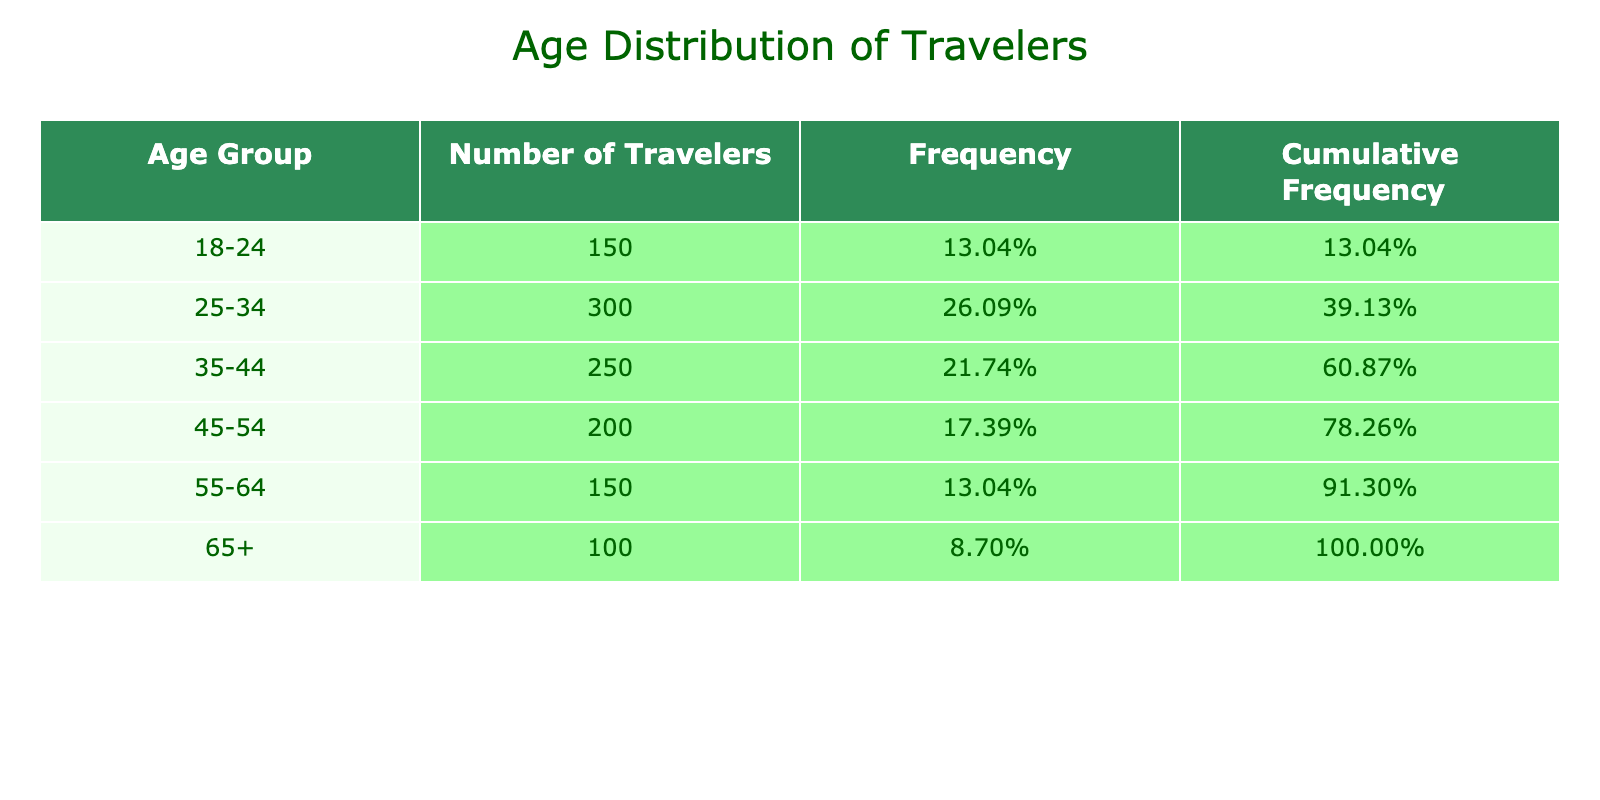What is the number of travelers in the age group 25-34? The table lists the number of travelers in each age group, and for the age group 25-34, it shows 300 travelers. This value can be found directly in the "Number of Travelers" column next to the "25-34" age group.
Answer: 300 Which age group has the highest number of travelers? By comparing the "Number of Travelers" in each age group listed, we can see that the age group 25-34 has the highest count with 300 travelers, more than any other group.
Answer: 25-34 What is the cumulative frequency for the age group 45-54? To find the cumulative frequency, we look at the cumulative frequency column for the age group 45-54, which shows 73.33%. This value reflects the total proportion of travelers that fall into this age group or younger.
Answer: 73.33% Is the number of travelers in the age group 65+ less than the number of travelers in the age group 35-44? The number of travelers aged 65+ is 100, while the 35-44 age group has 250 travelers. Since 100 is less than 250, the statement is true.
Answer: Yes What is the total number of travelers across all age groups? To find the total number of travelers, we add up the number of travelers from all age groups: 150 + 300 + 250 + 200 + 150 + 100 = 1150 travelers total. This sum represents the aggregate number of travelers using the service across all defined age groups.
Answer: 1150 What percentage of travelers are aged 55-64? First, we find the number of travelers in the 55-64 age group, which is 150. The total number of travelers is 1150 as calculated previously. The percentage is calculated by dividing 150 by 1150 and multiplying by 100, resulting in approximately 13.04%.
Answer: 13.04% Which age group represents more than 20% of the total number of travelers? We need to calculate 20% of the total number of travelers (1150), which is 230. The age groups 25-34 (300 travelers) and 35-44 (250 travelers) exceed this threshold. Both of these groups represent more than 20% of the total.
Answer: 25-34 and 35-44 How many travelers are in the age groups 45-54 and 55-64 combined? We add the number of travelers in the two age groups: 200 (45-54) + 150 (55-64) = 350 travelers. This value represents the total number of travelers in these two specific age ranges combined.
Answer: 350 Are there more travelers in the age group 18-24 compared to the age group 65+? The age group 18-24 has 150 travelers, while the age group 65+ has 100 travelers. Since 150 is greater than 100, the answer to the question is yes.
Answer: Yes 